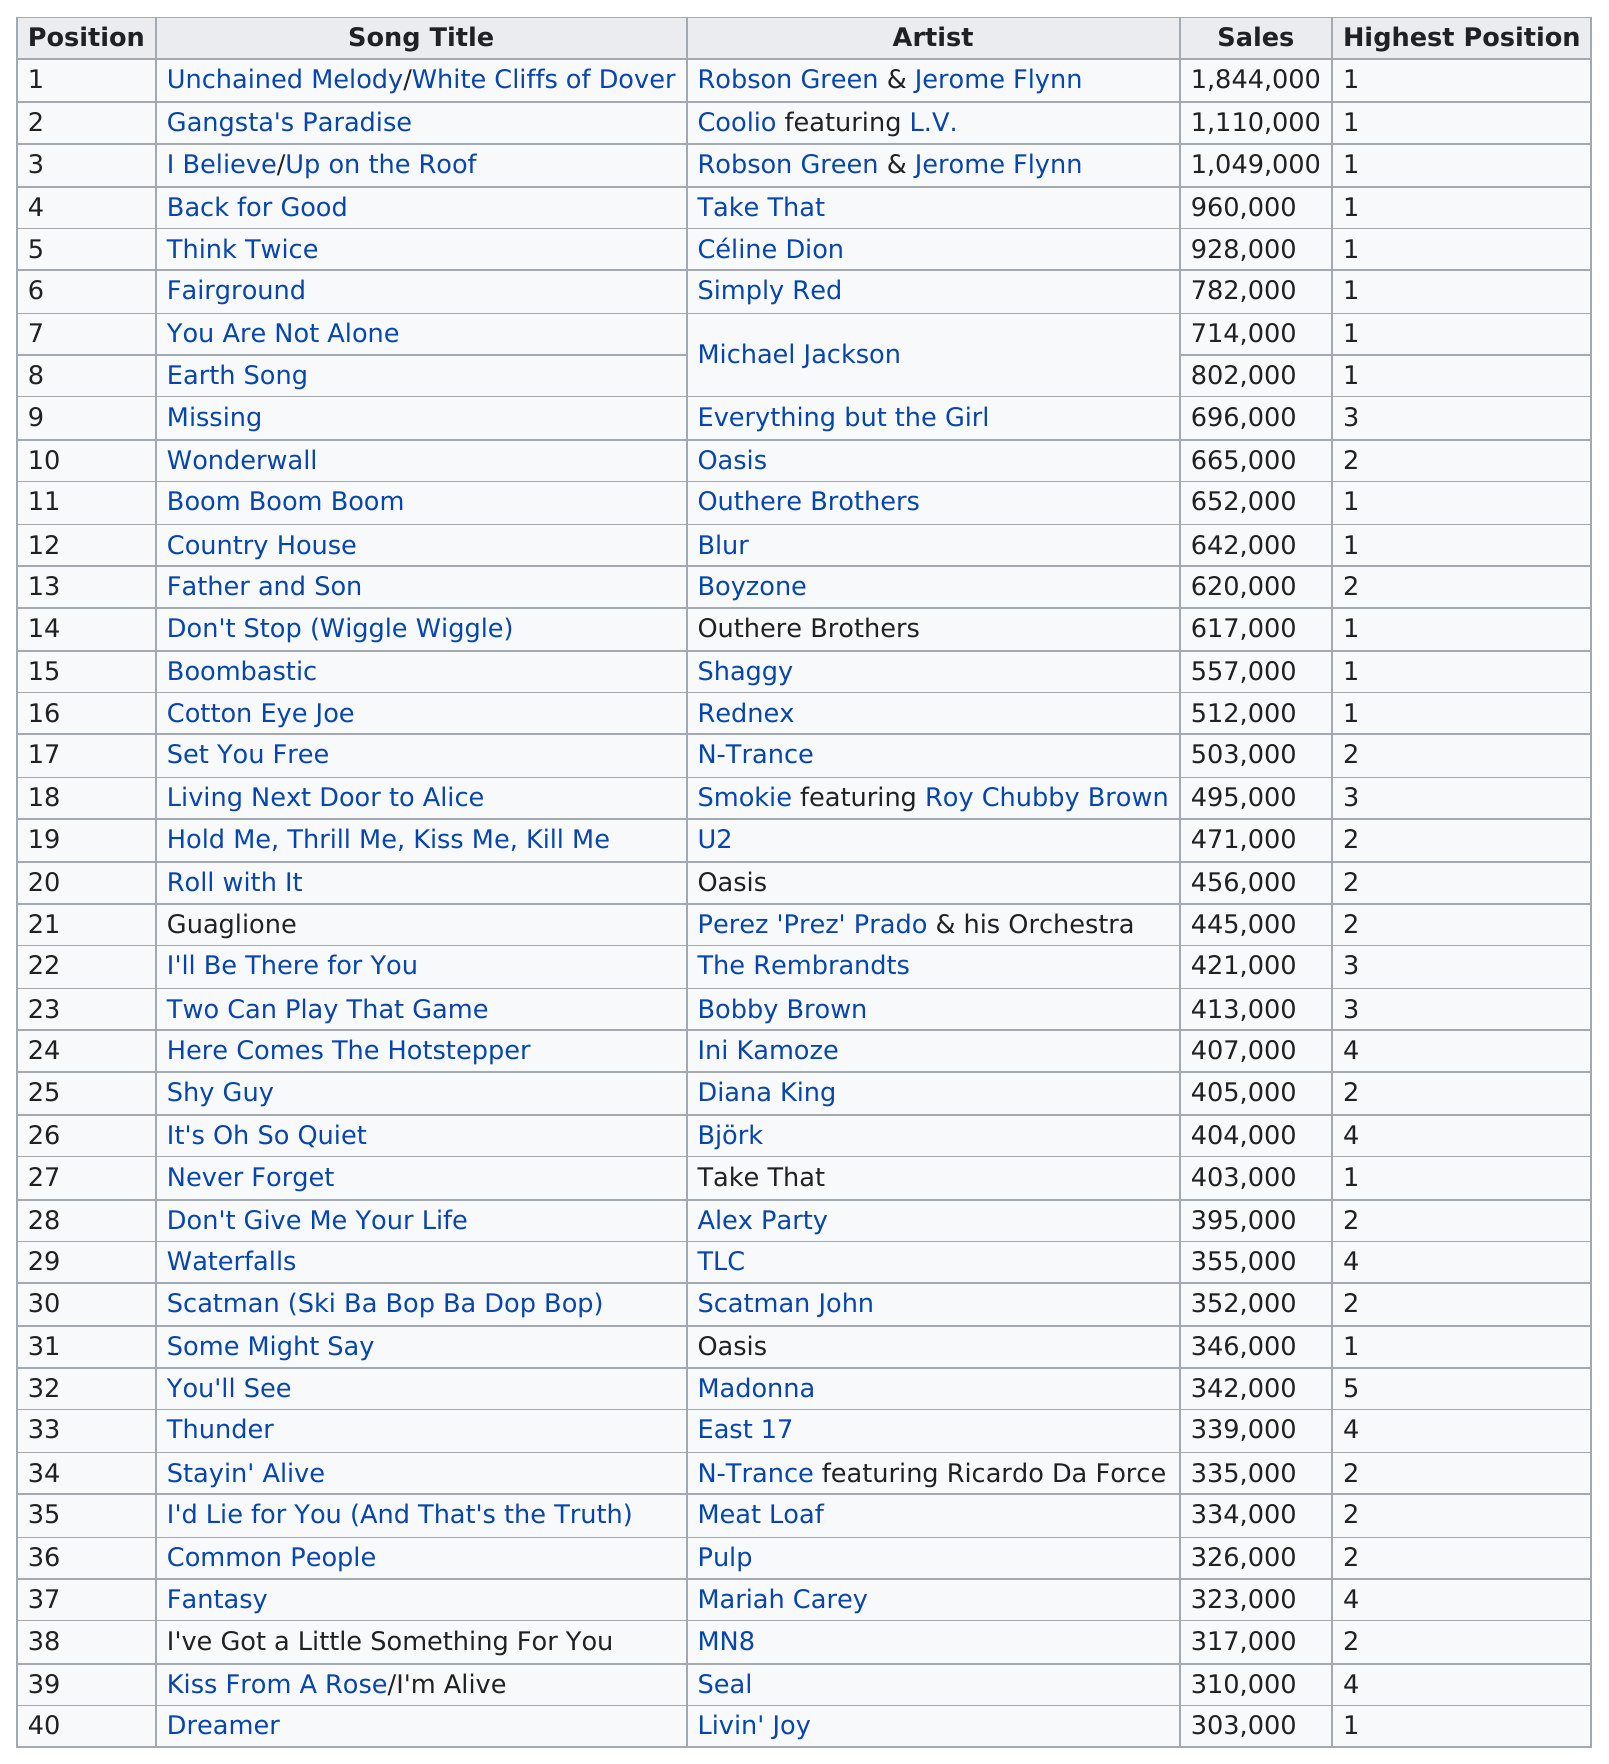Point out several critical features in this image. Madonna ranked 32nd on the Top 40 Singles of 1995 chart in 1995. In 1995, three singles topped 1,000,000 sales. The sales figures for "Think Twice" and "Back for Good" are 32,000 and 64,000 respectively. Out of the 16 songs that reached position 1 at their highest point, how many reached position 1 at their highest point? The song "Boombastic" made a total of 557,000 sales. 